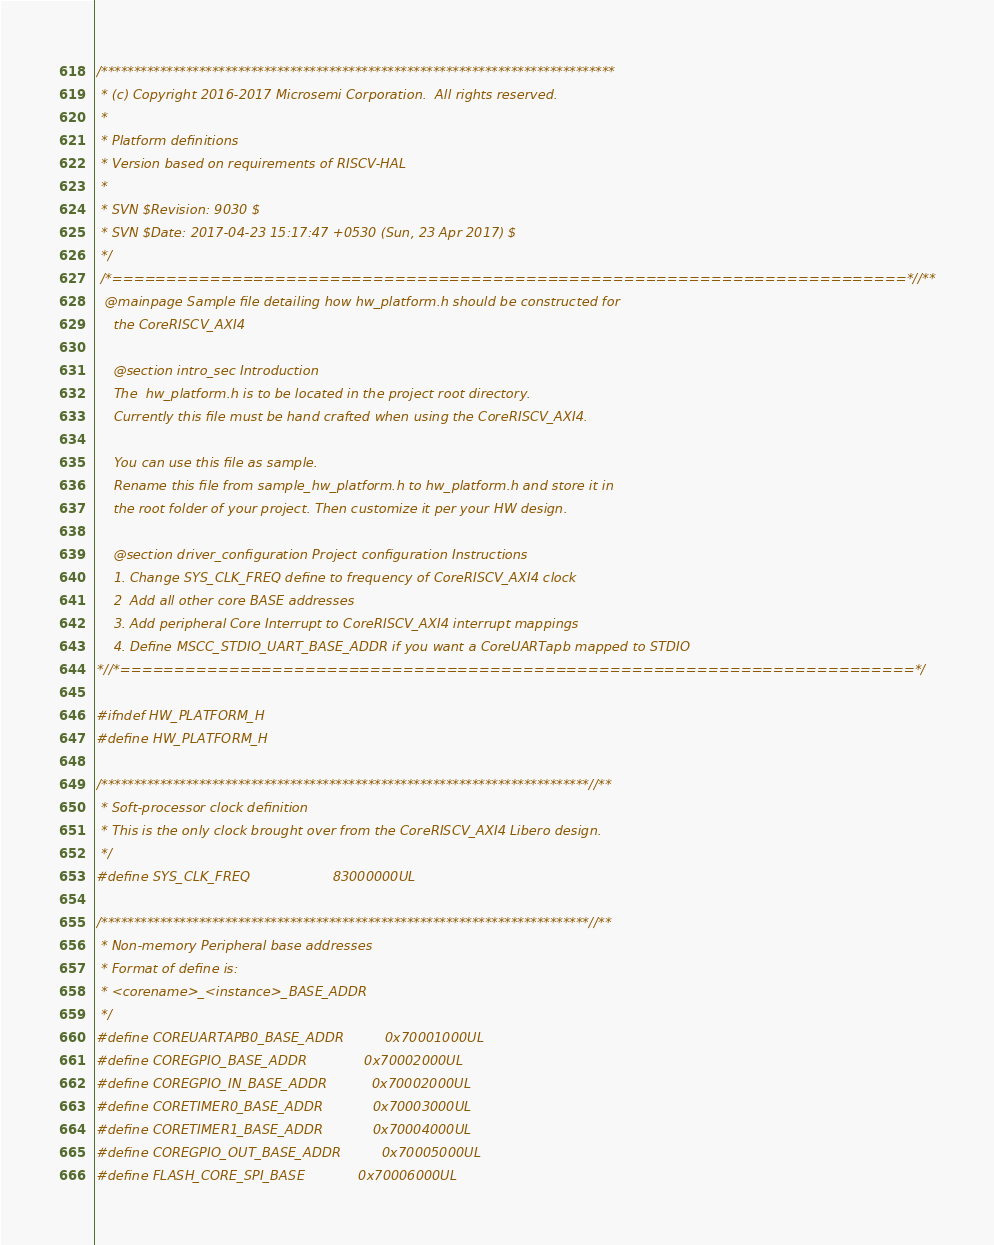Convert code to text. <code><loc_0><loc_0><loc_500><loc_500><_C_>/*******************************************************************************
 * (c) Copyright 2016-2017 Microsemi Corporation.  All rights reserved.
 *
 * Platform definitions
 * Version based on requirements of RISCV-HAL
 *
 * SVN $Revision: 9030 $
 * SVN $Date: 2017-04-23 15:17:47 +0530 (Sun, 23 Apr 2017) $
 */
 /*=========================================================================*//**
  @mainpage Sample file detailing how hw_platform.h should be constructed for 
    the CoreRISCV_AXI4

    @section intro_sec Introduction
    The  hw_platform.h is to be located in the project root directory.
    Currently this file must be hand crafted when using the CoreRISCV_AXI4.
    
    You can use this file as sample.
    Rename this file from sample_hw_platform.h to hw_platform.h and store it in
    the root folder of your project. Then customize it per your HW design.

    @section driver_configuration Project configuration Instructions
    1. Change SYS_CLK_FREQ define to frequency of CoreRISCV_AXI4 clock
    2  Add all other core BASE addresses
    3. Add peripheral Core Interrupt to CoreRISCV_AXI4 interrupt mappings
    4. Define MSCC_STDIO_UART_BASE_ADDR if you want a CoreUARTapb mapped to STDIO
*//*=========================================================================*/

#ifndef HW_PLATFORM_H
#define HW_PLATFORM_H

/***************************************************************************//**
 * Soft-processor clock definition
 * This is the only clock brought over from the CoreRISCV_AXI4 Libero design.
 */
#define SYS_CLK_FREQ                    83000000UL

/***************************************************************************//**
 * Non-memory Peripheral base addresses
 * Format of define is:
 * <corename>_<instance>_BASE_ADDR
 */
#define COREUARTAPB0_BASE_ADDR          0x70001000UL
#define COREGPIO_BASE_ADDR              0x70002000UL
#define COREGPIO_IN_BASE_ADDR           0x70002000UL
#define CORETIMER0_BASE_ADDR            0x70003000UL
#define CORETIMER1_BASE_ADDR            0x70004000UL
#define COREGPIO_OUT_BASE_ADDR          0x70005000UL
#define FLASH_CORE_SPI_BASE             0x70006000UL</code> 